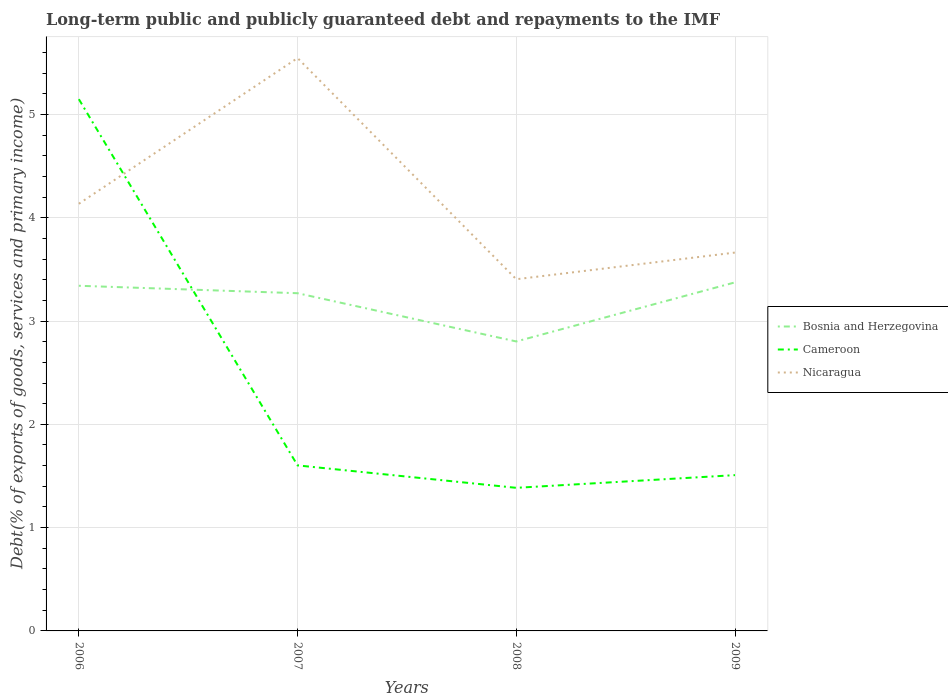Across all years, what is the maximum debt and repayments in Bosnia and Herzegovina?
Make the answer very short. 2.8. In which year was the debt and repayments in Nicaragua maximum?
Give a very brief answer. 2008. What is the total debt and repayments in Nicaragua in the graph?
Give a very brief answer. 1.88. What is the difference between the highest and the second highest debt and repayments in Bosnia and Herzegovina?
Your answer should be compact. 0.57. What is the difference between the highest and the lowest debt and repayments in Cameroon?
Make the answer very short. 1. What is the difference between two consecutive major ticks on the Y-axis?
Ensure brevity in your answer.  1. Are the values on the major ticks of Y-axis written in scientific E-notation?
Your answer should be compact. No. Does the graph contain any zero values?
Ensure brevity in your answer.  No. Does the graph contain grids?
Your answer should be very brief. Yes. Where does the legend appear in the graph?
Make the answer very short. Center right. How are the legend labels stacked?
Provide a short and direct response. Vertical. What is the title of the graph?
Make the answer very short. Long-term public and publicly guaranteed debt and repayments to the IMF. What is the label or title of the Y-axis?
Provide a short and direct response. Debt(% of exports of goods, services and primary income). What is the Debt(% of exports of goods, services and primary income) of Bosnia and Herzegovina in 2006?
Offer a terse response. 3.34. What is the Debt(% of exports of goods, services and primary income) in Cameroon in 2006?
Provide a short and direct response. 5.15. What is the Debt(% of exports of goods, services and primary income) in Nicaragua in 2006?
Your answer should be very brief. 4.14. What is the Debt(% of exports of goods, services and primary income) in Bosnia and Herzegovina in 2007?
Your answer should be compact. 3.27. What is the Debt(% of exports of goods, services and primary income) of Cameroon in 2007?
Your response must be concise. 1.6. What is the Debt(% of exports of goods, services and primary income) of Nicaragua in 2007?
Offer a terse response. 5.55. What is the Debt(% of exports of goods, services and primary income) in Bosnia and Herzegovina in 2008?
Offer a very short reply. 2.8. What is the Debt(% of exports of goods, services and primary income) in Cameroon in 2008?
Your answer should be compact. 1.39. What is the Debt(% of exports of goods, services and primary income) of Nicaragua in 2008?
Offer a very short reply. 3.4. What is the Debt(% of exports of goods, services and primary income) in Bosnia and Herzegovina in 2009?
Your response must be concise. 3.37. What is the Debt(% of exports of goods, services and primary income) in Cameroon in 2009?
Ensure brevity in your answer.  1.51. What is the Debt(% of exports of goods, services and primary income) of Nicaragua in 2009?
Give a very brief answer. 3.66. Across all years, what is the maximum Debt(% of exports of goods, services and primary income) in Bosnia and Herzegovina?
Your response must be concise. 3.37. Across all years, what is the maximum Debt(% of exports of goods, services and primary income) of Cameroon?
Offer a terse response. 5.15. Across all years, what is the maximum Debt(% of exports of goods, services and primary income) of Nicaragua?
Provide a short and direct response. 5.55. Across all years, what is the minimum Debt(% of exports of goods, services and primary income) of Bosnia and Herzegovina?
Keep it short and to the point. 2.8. Across all years, what is the minimum Debt(% of exports of goods, services and primary income) in Cameroon?
Provide a succinct answer. 1.39. Across all years, what is the minimum Debt(% of exports of goods, services and primary income) in Nicaragua?
Provide a short and direct response. 3.4. What is the total Debt(% of exports of goods, services and primary income) of Bosnia and Herzegovina in the graph?
Provide a short and direct response. 12.79. What is the total Debt(% of exports of goods, services and primary income) in Cameroon in the graph?
Offer a terse response. 9.64. What is the total Debt(% of exports of goods, services and primary income) of Nicaragua in the graph?
Provide a short and direct response. 16.75. What is the difference between the Debt(% of exports of goods, services and primary income) of Bosnia and Herzegovina in 2006 and that in 2007?
Your response must be concise. 0.07. What is the difference between the Debt(% of exports of goods, services and primary income) in Cameroon in 2006 and that in 2007?
Your answer should be very brief. 3.55. What is the difference between the Debt(% of exports of goods, services and primary income) of Nicaragua in 2006 and that in 2007?
Keep it short and to the point. -1.41. What is the difference between the Debt(% of exports of goods, services and primary income) of Bosnia and Herzegovina in 2006 and that in 2008?
Make the answer very short. 0.54. What is the difference between the Debt(% of exports of goods, services and primary income) of Cameroon in 2006 and that in 2008?
Keep it short and to the point. 3.76. What is the difference between the Debt(% of exports of goods, services and primary income) of Nicaragua in 2006 and that in 2008?
Your response must be concise. 0.73. What is the difference between the Debt(% of exports of goods, services and primary income) of Bosnia and Herzegovina in 2006 and that in 2009?
Your answer should be compact. -0.03. What is the difference between the Debt(% of exports of goods, services and primary income) in Cameroon in 2006 and that in 2009?
Your answer should be very brief. 3.64. What is the difference between the Debt(% of exports of goods, services and primary income) of Nicaragua in 2006 and that in 2009?
Offer a very short reply. 0.47. What is the difference between the Debt(% of exports of goods, services and primary income) in Bosnia and Herzegovina in 2007 and that in 2008?
Give a very brief answer. 0.47. What is the difference between the Debt(% of exports of goods, services and primary income) in Cameroon in 2007 and that in 2008?
Offer a very short reply. 0.22. What is the difference between the Debt(% of exports of goods, services and primary income) of Nicaragua in 2007 and that in 2008?
Your answer should be compact. 2.14. What is the difference between the Debt(% of exports of goods, services and primary income) in Bosnia and Herzegovina in 2007 and that in 2009?
Ensure brevity in your answer.  -0.1. What is the difference between the Debt(% of exports of goods, services and primary income) of Cameroon in 2007 and that in 2009?
Ensure brevity in your answer.  0.09. What is the difference between the Debt(% of exports of goods, services and primary income) of Nicaragua in 2007 and that in 2009?
Make the answer very short. 1.88. What is the difference between the Debt(% of exports of goods, services and primary income) in Bosnia and Herzegovina in 2008 and that in 2009?
Your answer should be very brief. -0.57. What is the difference between the Debt(% of exports of goods, services and primary income) of Cameroon in 2008 and that in 2009?
Ensure brevity in your answer.  -0.12. What is the difference between the Debt(% of exports of goods, services and primary income) in Nicaragua in 2008 and that in 2009?
Provide a succinct answer. -0.26. What is the difference between the Debt(% of exports of goods, services and primary income) in Bosnia and Herzegovina in 2006 and the Debt(% of exports of goods, services and primary income) in Cameroon in 2007?
Ensure brevity in your answer.  1.74. What is the difference between the Debt(% of exports of goods, services and primary income) of Bosnia and Herzegovina in 2006 and the Debt(% of exports of goods, services and primary income) of Nicaragua in 2007?
Give a very brief answer. -2.2. What is the difference between the Debt(% of exports of goods, services and primary income) of Cameroon in 2006 and the Debt(% of exports of goods, services and primary income) of Nicaragua in 2007?
Give a very brief answer. -0.4. What is the difference between the Debt(% of exports of goods, services and primary income) of Bosnia and Herzegovina in 2006 and the Debt(% of exports of goods, services and primary income) of Cameroon in 2008?
Your response must be concise. 1.96. What is the difference between the Debt(% of exports of goods, services and primary income) of Bosnia and Herzegovina in 2006 and the Debt(% of exports of goods, services and primary income) of Nicaragua in 2008?
Ensure brevity in your answer.  -0.06. What is the difference between the Debt(% of exports of goods, services and primary income) of Cameroon in 2006 and the Debt(% of exports of goods, services and primary income) of Nicaragua in 2008?
Give a very brief answer. 1.74. What is the difference between the Debt(% of exports of goods, services and primary income) of Bosnia and Herzegovina in 2006 and the Debt(% of exports of goods, services and primary income) of Cameroon in 2009?
Provide a short and direct response. 1.83. What is the difference between the Debt(% of exports of goods, services and primary income) in Bosnia and Herzegovina in 2006 and the Debt(% of exports of goods, services and primary income) in Nicaragua in 2009?
Offer a very short reply. -0.32. What is the difference between the Debt(% of exports of goods, services and primary income) in Cameroon in 2006 and the Debt(% of exports of goods, services and primary income) in Nicaragua in 2009?
Offer a very short reply. 1.49. What is the difference between the Debt(% of exports of goods, services and primary income) of Bosnia and Herzegovina in 2007 and the Debt(% of exports of goods, services and primary income) of Cameroon in 2008?
Ensure brevity in your answer.  1.88. What is the difference between the Debt(% of exports of goods, services and primary income) in Bosnia and Herzegovina in 2007 and the Debt(% of exports of goods, services and primary income) in Nicaragua in 2008?
Make the answer very short. -0.14. What is the difference between the Debt(% of exports of goods, services and primary income) in Cameroon in 2007 and the Debt(% of exports of goods, services and primary income) in Nicaragua in 2008?
Your answer should be very brief. -1.8. What is the difference between the Debt(% of exports of goods, services and primary income) of Bosnia and Herzegovina in 2007 and the Debt(% of exports of goods, services and primary income) of Cameroon in 2009?
Offer a very short reply. 1.76. What is the difference between the Debt(% of exports of goods, services and primary income) in Bosnia and Herzegovina in 2007 and the Debt(% of exports of goods, services and primary income) in Nicaragua in 2009?
Offer a terse response. -0.39. What is the difference between the Debt(% of exports of goods, services and primary income) of Cameroon in 2007 and the Debt(% of exports of goods, services and primary income) of Nicaragua in 2009?
Ensure brevity in your answer.  -2.06. What is the difference between the Debt(% of exports of goods, services and primary income) of Bosnia and Herzegovina in 2008 and the Debt(% of exports of goods, services and primary income) of Cameroon in 2009?
Ensure brevity in your answer.  1.29. What is the difference between the Debt(% of exports of goods, services and primary income) in Bosnia and Herzegovina in 2008 and the Debt(% of exports of goods, services and primary income) in Nicaragua in 2009?
Your answer should be compact. -0.86. What is the difference between the Debt(% of exports of goods, services and primary income) of Cameroon in 2008 and the Debt(% of exports of goods, services and primary income) of Nicaragua in 2009?
Your response must be concise. -2.28. What is the average Debt(% of exports of goods, services and primary income) in Bosnia and Herzegovina per year?
Offer a very short reply. 3.2. What is the average Debt(% of exports of goods, services and primary income) of Cameroon per year?
Offer a very short reply. 2.41. What is the average Debt(% of exports of goods, services and primary income) in Nicaragua per year?
Provide a short and direct response. 4.19. In the year 2006, what is the difference between the Debt(% of exports of goods, services and primary income) in Bosnia and Herzegovina and Debt(% of exports of goods, services and primary income) in Cameroon?
Ensure brevity in your answer.  -1.81. In the year 2006, what is the difference between the Debt(% of exports of goods, services and primary income) in Bosnia and Herzegovina and Debt(% of exports of goods, services and primary income) in Nicaragua?
Ensure brevity in your answer.  -0.79. In the year 2006, what is the difference between the Debt(% of exports of goods, services and primary income) in Cameroon and Debt(% of exports of goods, services and primary income) in Nicaragua?
Make the answer very short. 1.01. In the year 2007, what is the difference between the Debt(% of exports of goods, services and primary income) in Bosnia and Herzegovina and Debt(% of exports of goods, services and primary income) in Cameroon?
Offer a very short reply. 1.67. In the year 2007, what is the difference between the Debt(% of exports of goods, services and primary income) in Bosnia and Herzegovina and Debt(% of exports of goods, services and primary income) in Nicaragua?
Keep it short and to the point. -2.28. In the year 2007, what is the difference between the Debt(% of exports of goods, services and primary income) of Cameroon and Debt(% of exports of goods, services and primary income) of Nicaragua?
Your answer should be very brief. -3.94. In the year 2008, what is the difference between the Debt(% of exports of goods, services and primary income) of Bosnia and Herzegovina and Debt(% of exports of goods, services and primary income) of Cameroon?
Your response must be concise. 1.42. In the year 2008, what is the difference between the Debt(% of exports of goods, services and primary income) in Bosnia and Herzegovina and Debt(% of exports of goods, services and primary income) in Nicaragua?
Make the answer very short. -0.6. In the year 2008, what is the difference between the Debt(% of exports of goods, services and primary income) of Cameroon and Debt(% of exports of goods, services and primary income) of Nicaragua?
Offer a very short reply. -2.02. In the year 2009, what is the difference between the Debt(% of exports of goods, services and primary income) of Bosnia and Herzegovina and Debt(% of exports of goods, services and primary income) of Cameroon?
Ensure brevity in your answer.  1.87. In the year 2009, what is the difference between the Debt(% of exports of goods, services and primary income) in Bosnia and Herzegovina and Debt(% of exports of goods, services and primary income) in Nicaragua?
Keep it short and to the point. -0.29. In the year 2009, what is the difference between the Debt(% of exports of goods, services and primary income) of Cameroon and Debt(% of exports of goods, services and primary income) of Nicaragua?
Keep it short and to the point. -2.15. What is the ratio of the Debt(% of exports of goods, services and primary income) in Bosnia and Herzegovina in 2006 to that in 2007?
Provide a succinct answer. 1.02. What is the ratio of the Debt(% of exports of goods, services and primary income) of Cameroon in 2006 to that in 2007?
Make the answer very short. 3.21. What is the ratio of the Debt(% of exports of goods, services and primary income) of Nicaragua in 2006 to that in 2007?
Your answer should be very brief. 0.75. What is the ratio of the Debt(% of exports of goods, services and primary income) of Bosnia and Herzegovina in 2006 to that in 2008?
Make the answer very short. 1.19. What is the ratio of the Debt(% of exports of goods, services and primary income) of Cameroon in 2006 to that in 2008?
Provide a succinct answer. 3.72. What is the ratio of the Debt(% of exports of goods, services and primary income) in Nicaragua in 2006 to that in 2008?
Give a very brief answer. 1.21. What is the ratio of the Debt(% of exports of goods, services and primary income) in Bosnia and Herzegovina in 2006 to that in 2009?
Make the answer very short. 0.99. What is the ratio of the Debt(% of exports of goods, services and primary income) of Cameroon in 2006 to that in 2009?
Offer a very short reply. 3.41. What is the ratio of the Debt(% of exports of goods, services and primary income) in Nicaragua in 2006 to that in 2009?
Your response must be concise. 1.13. What is the ratio of the Debt(% of exports of goods, services and primary income) of Bosnia and Herzegovina in 2007 to that in 2008?
Offer a terse response. 1.17. What is the ratio of the Debt(% of exports of goods, services and primary income) of Cameroon in 2007 to that in 2008?
Provide a short and direct response. 1.16. What is the ratio of the Debt(% of exports of goods, services and primary income) in Nicaragua in 2007 to that in 2008?
Make the answer very short. 1.63. What is the ratio of the Debt(% of exports of goods, services and primary income) in Bosnia and Herzegovina in 2007 to that in 2009?
Offer a terse response. 0.97. What is the ratio of the Debt(% of exports of goods, services and primary income) in Nicaragua in 2007 to that in 2009?
Provide a succinct answer. 1.51. What is the ratio of the Debt(% of exports of goods, services and primary income) in Bosnia and Herzegovina in 2008 to that in 2009?
Provide a succinct answer. 0.83. What is the ratio of the Debt(% of exports of goods, services and primary income) of Cameroon in 2008 to that in 2009?
Your answer should be compact. 0.92. What is the ratio of the Debt(% of exports of goods, services and primary income) of Nicaragua in 2008 to that in 2009?
Your response must be concise. 0.93. What is the difference between the highest and the second highest Debt(% of exports of goods, services and primary income) in Bosnia and Herzegovina?
Your answer should be very brief. 0.03. What is the difference between the highest and the second highest Debt(% of exports of goods, services and primary income) in Cameroon?
Offer a terse response. 3.55. What is the difference between the highest and the second highest Debt(% of exports of goods, services and primary income) in Nicaragua?
Offer a terse response. 1.41. What is the difference between the highest and the lowest Debt(% of exports of goods, services and primary income) in Bosnia and Herzegovina?
Your response must be concise. 0.57. What is the difference between the highest and the lowest Debt(% of exports of goods, services and primary income) in Cameroon?
Offer a terse response. 3.76. What is the difference between the highest and the lowest Debt(% of exports of goods, services and primary income) in Nicaragua?
Ensure brevity in your answer.  2.14. 